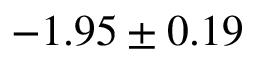<formula> <loc_0><loc_0><loc_500><loc_500>- 1 . 9 5 \pm 0 . 1 9</formula> 